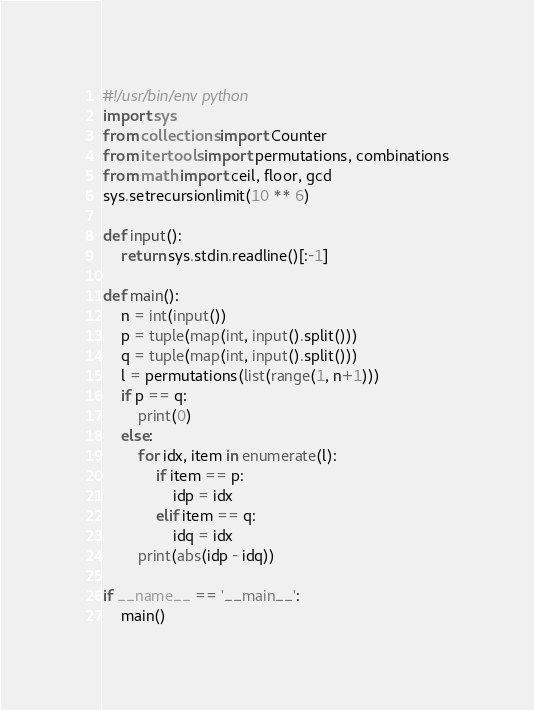<code> <loc_0><loc_0><loc_500><loc_500><_Python_>#!/usr/bin/env python
import sys
from collections import Counter
from itertools import permutations, combinations
from math import ceil, floor, gcd
sys.setrecursionlimit(10 ** 6)

def input():
    return sys.stdin.readline()[:-1]

def main():
    n = int(input())
    p = tuple(map(int, input().split()))
    q = tuple(map(int, input().split()))
    l = permutations(list(range(1, n+1)))
    if p == q:
        print(0)
    else:
        for idx, item in enumerate(l):
            if item == p:
                idp = idx
            elif item == q:
                idq = idx
        print(abs(idp - idq))

if __name__ == '__main__':
    main()</code> 